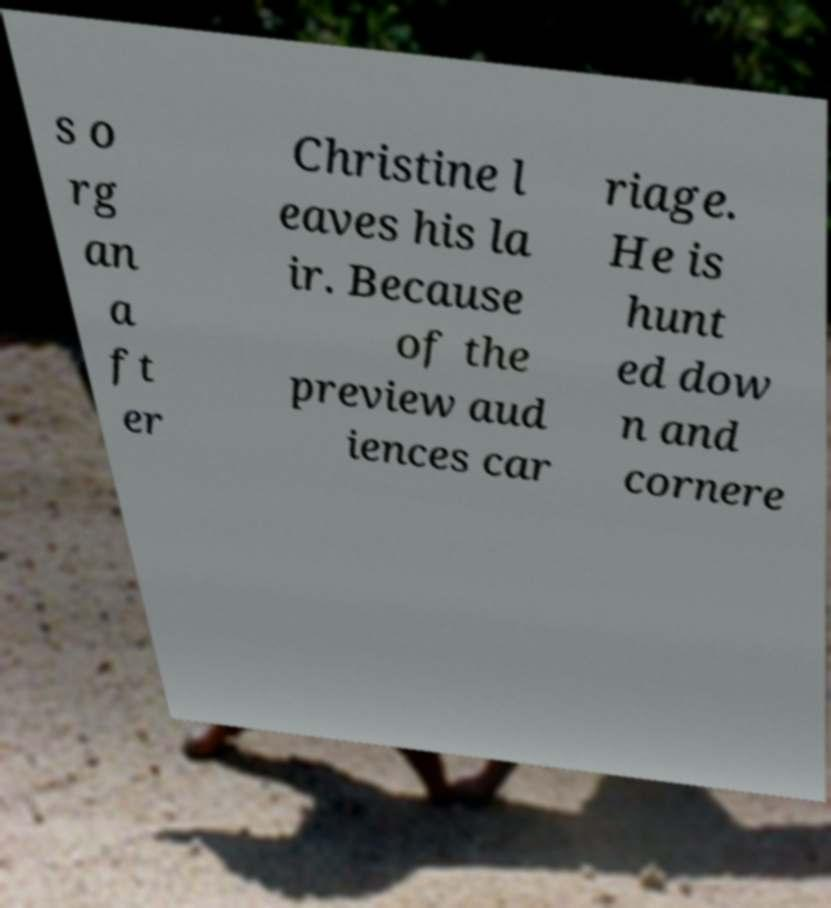Can you accurately transcribe the text from the provided image for me? s o rg an a ft er Christine l eaves his la ir. Because of the preview aud iences car riage. He is hunt ed dow n and cornere 